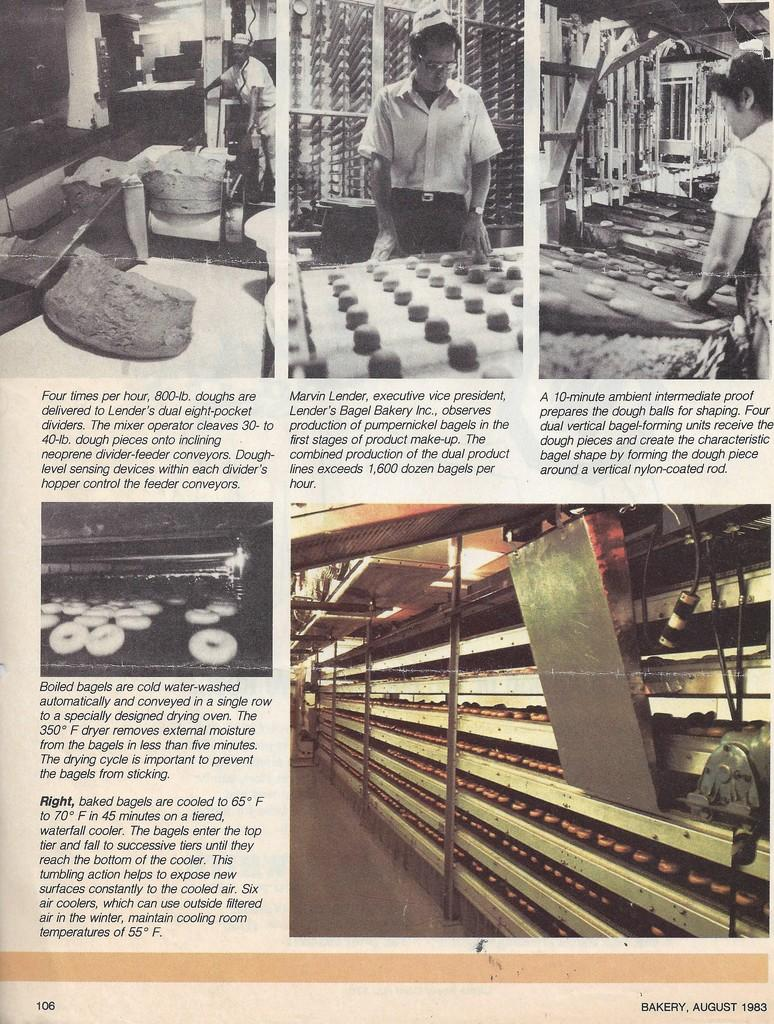What is the main object in the image? There is a newspaper in the image. What might the newspaper be used for? The newspaper might be used for reading news, articles, or other information. Can you describe the appearance of the newspaper? The newspaper appears to be folded and may have some pages visible. What advice does the newspaper give about religion in the image? There is no advice or discussion about religion in the image; it only features a newspaper. 